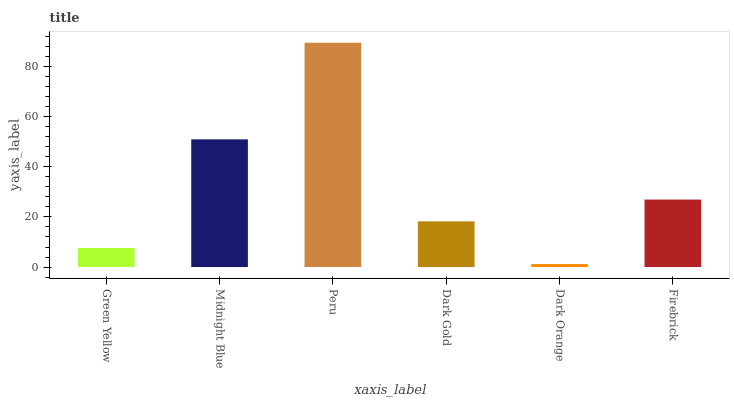Is Dark Orange the minimum?
Answer yes or no. Yes. Is Peru the maximum?
Answer yes or no. Yes. Is Midnight Blue the minimum?
Answer yes or no. No. Is Midnight Blue the maximum?
Answer yes or no. No. Is Midnight Blue greater than Green Yellow?
Answer yes or no. Yes. Is Green Yellow less than Midnight Blue?
Answer yes or no. Yes. Is Green Yellow greater than Midnight Blue?
Answer yes or no. No. Is Midnight Blue less than Green Yellow?
Answer yes or no. No. Is Firebrick the high median?
Answer yes or no. Yes. Is Dark Gold the low median?
Answer yes or no. Yes. Is Peru the high median?
Answer yes or no. No. Is Peru the low median?
Answer yes or no. No. 